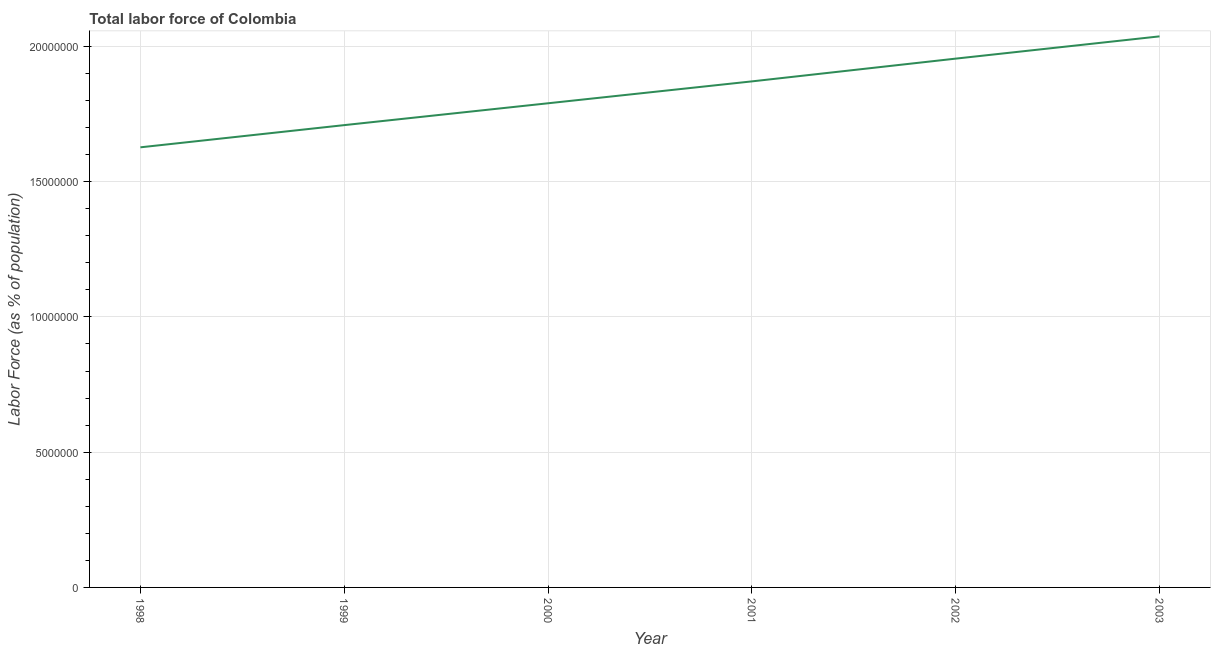What is the total labor force in 2001?
Provide a short and direct response. 1.87e+07. Across all years, what is the maximum total labor force?
Keep it short and to the point. 2.04e+07. Across all years, what is the minimum total labor force?
Make the answer very short. 1.63e+07. What is the sum of the total labor force?
Your answer should be compact. 1.10e+08. What is the difference between the total labor force in 2000 and 2002?
Offer a terse response. -1.65e+06. What is the average total labor force per year?
Make the answer very short. 1.83e+07. What is the median total labor force?
Offer a very short reply. 1.83e+07. In how many years, is the total labor force greater than 9000000 %?
Offer a very short reply. 6. Do a majority of the years between 1998 and 2002 (inclusive) have total labor force greater than 9000000 %?
Your answer should be very brief. Yes. What is the ratio of the total labor force in 1998 to that in 2000?
Make the answer very short. 0.91. Is the total labor force in 1998 less than that in 2003?
Offer a terse response. Yes. What is the difference between the highest and the second highest total labor force?
Your answer should be very brief. 8.23e+05. Is the sum of the total labor force in 1998 and 2002 greater than the maximum total labor force across all years?
Offer a very short reply. Yes. What is the difference between the highest and the lowest total labor force?
Make the answer very short. 4.10e+06. Does the total labor force monotonically increase over the years?
Your answer should be very brief. Yes. How many lines are there?
Ensure brevity in your answer.  1. What is the difference between two consecutive major ticks on the Y-axis?
Provide a short and direct response. 5.00e+06. Are the values on the major ticks of Y-axis written in scientific E-notation?
Offer a terse response. No. What is the title of the graph?
Keep it short and to the point. Total labor force of Colombia. What is the label or title of the Y-axis?
Your response must be concise. Labor Force (as % of population). What is the Labor Force (as % of population) in 1998?
Make the answer very short. 1.63e+07. What is the Labor Force (as % of population) of 1999?
Offer a terse response. 1.71e+07. What is the Labor Force (as % of population) of 2000?
Provide a succinct answer. 1.79e+07. What is the Labor Force (as % of population) of 2001?
Offer a very short reply. 1.87e+07. What is the Labor Force (as % of population) of 2002?
Offer a very short reply. 1.95e+07. What is the Labor Force (as % of population) of 2003?
Give a very brief answer. 2.04e+07. What is the difference between the Labor Force (as % of population) in 1998 and 1999?
Provide a short and direct response. -8.20e+05. What is the difference between the Labor Force (as % of population) in 1998 and 2000?
Offer a terse response. -1.63e+06. What is the difference between the Labor Force (as % of population) in 1998 and 2001?
Ensure brevity in your answer.  -2.44e+06. What is the difference between the Labor Force (as % of population) in 1998 and 2002?
Provide a succinct answer. -3.28e+06. What is the difference between the Labor Force (as % of population) in 1998 and 2003?
Offer a terse response. -4.10e+06. What is the difference between the Labor Force (as % of population) in 1999 and 2000?
Provide a short and direct response. -8.08e+05. What is the difference between the Labor Force (as % of population) in 1999 and 2001?
Ensure brevity in your answer.  -1.62e+06. What is the difference between the Labor Force (as % of population) in 1999 and 2002?
Offer a terse response. -2.46e+06. What is the difference between the Labor Force (as % of population) in 1999 and 2003?
Offer a terse response. -3.28e+06. What is the difference between the Labor Force (as % of population) in 2000 and 2001?
Provide a short and direct response. -8.09e+05. What is the difference between the Labor Force (as % of population) in 2000 and 2002?
Provide a short and direct response. -1.65e+06. What is the difference between the Labor Force (as % of population) in 2000 and 2003?
Your answer should be compact. -2.47e+06. What is the difference between the Labor Force (as % of population) in 2001 and 2002?
Provide a succinct answer. -8.42e+05. What is the difference between the Labor Force (as % of population) in 2001 and 2003?
Keep it short and to the point. -1.66e+06. What is the difference between the Labor Force (as % of population) in 2002 and 2003?
Give a very brief answer. -8.23e+05. What is the ratio of the Labor Force (as % of population) in 1998 to that in 1999?
Offer a terse response. 0.95. What is the ratio of the Labor Force (as % of population) in 1998 to that in 2000?
Give a very brief answer. 0.91. What is the ratio of the Labor Force (as % of population) in 1998 to that in 2001?
Make the answer very short. 0.87. What is the ratio of the Labor Force (as % of population) in 1998 to that in 2002?
Your answer should be compact. 0.83. What is the ratio of the Labor Force (as % of population) in 1998 to that in 2003?
Keep it short and to the point. 0.8. What is the ratio of the Labor Force (as % of population) in 1999 to that in 2000?
Your answer should be compact. 0.95. What is the ratio of the Labor Force (as % of population) in 1999 to that in 2001?
Your response must be concise. 0.91. What is the ratio of the Labor Force (as % of population) in 1999 to that in 2002?
Offer a very short reply. 0.87. What is the ratio of the Labor Force (as % of population) in 1999 to that in 2003?
Your answer should be very brief. 0.84. What is the ratio of the Labor Force (as % of population) in 2000 to that in 2002?
Your answer should be very brief. 0.92. What is the ratio of the Labor Force (as % of population) in 2000 to that in 2003?
Ensure brevity in your answer.  0.88. What is the ratio of the Labor Force (as % of population) in 2001 to that in 2003?
Your response must be concise. 0.92. 